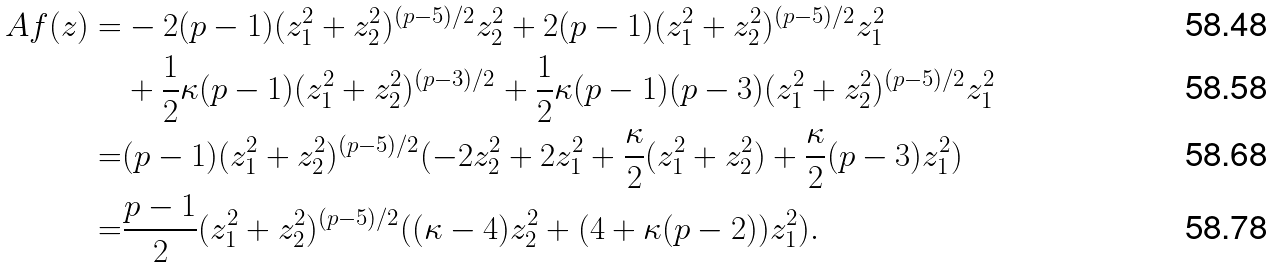<formula> <loc_0><loc_0><loc_500><loc_500>A f ( z ) = & - 2 ( p - 1 ) ( z _ { 1 } ^ { 2 } + z _ { 2 } ^ { 2 } ) ^ { ( p - 5 ) / 2 } z _ { 2 } ^ { 2 } + 2 ( p - 1 ) ( z _ { 1 } ^ { 2 } + z _ { 2 } ^ { 2 } ) ^ { ( p - 5 ) / 2 } z _ { 1 } ^ { 2 } \\ & + \frac { 1 } { 2 } \kappa ( p - 1 ) ( z _ { 1 } ^ { 2 } + z _ { 2 } ^ { 2 } ) ^ { ( p - 3 ) / 2 } + \frac { 1 } { 2 } \kappa ( p - 1 ) ( p - 3 ) ( z _ { 1 } ^ { 2 } + z _ { 2 } ^ { 2 } ) ^ { ( p - 5 ) / 2 } z _ { 1 } ^ { 2 } \\ = & ( p - 1 ) ( z _ { 1 } ^ { 2 } + z _ { 2 } ^ { 2 } ) ^ { ( p - 5 ) / 2 } ( - 2 z _ { 2 } ^ { 2 } + 2 z _ { 1 } ^ { 2 } + \frac { \kappa } { 2 } ( z _ { 1 } ^ { 2 } + z _ { 2 } ^ { 2 } ) + \frac { \kappa } { 2 } ( p - 3 ) z _ { 1 } ^ { 2 } ) \\ = & \frac { p - 1 } { 2 } ( z _ { 1 } ^ { 2 } + z _ { 2 } ^ { 2 } ) ^ { ( p - 5 ) / 2 } ( ( \kappa - 4 ) z _ { 2 } ^ { 2 } + ( 4 + \kappa ( p - 2 ) ) z _ { 1 } ^ { 2 } ) .</formula> 